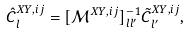Convert formula to latex. <formula><loc_0><loc_0><loc_500><loc_500>\hat { C } _ { l } ^ { X Y , i j } = [ \mathcal { M } ^ { X Y , i j } ] ^ { - 1 } _ { l l ^ { \prime } } \tilde { C } _ { l ^ { \prime } } ^ { X Y , i j } ,</formula> 